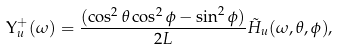Convert formula to latex. <formula><loc_0><loc_0><loc_500><loc_500>\Upsilon _ { u } ^ { + } ( \omega ) = \frac { ( \cos ^ { 2 } \theta \cos ^ { 2 } \phi - \sin ^ { 2 } \phi ) } { 2 L } \tilde { H } _ { u } ( \omega , \theta , \phi ) ,</formula> 